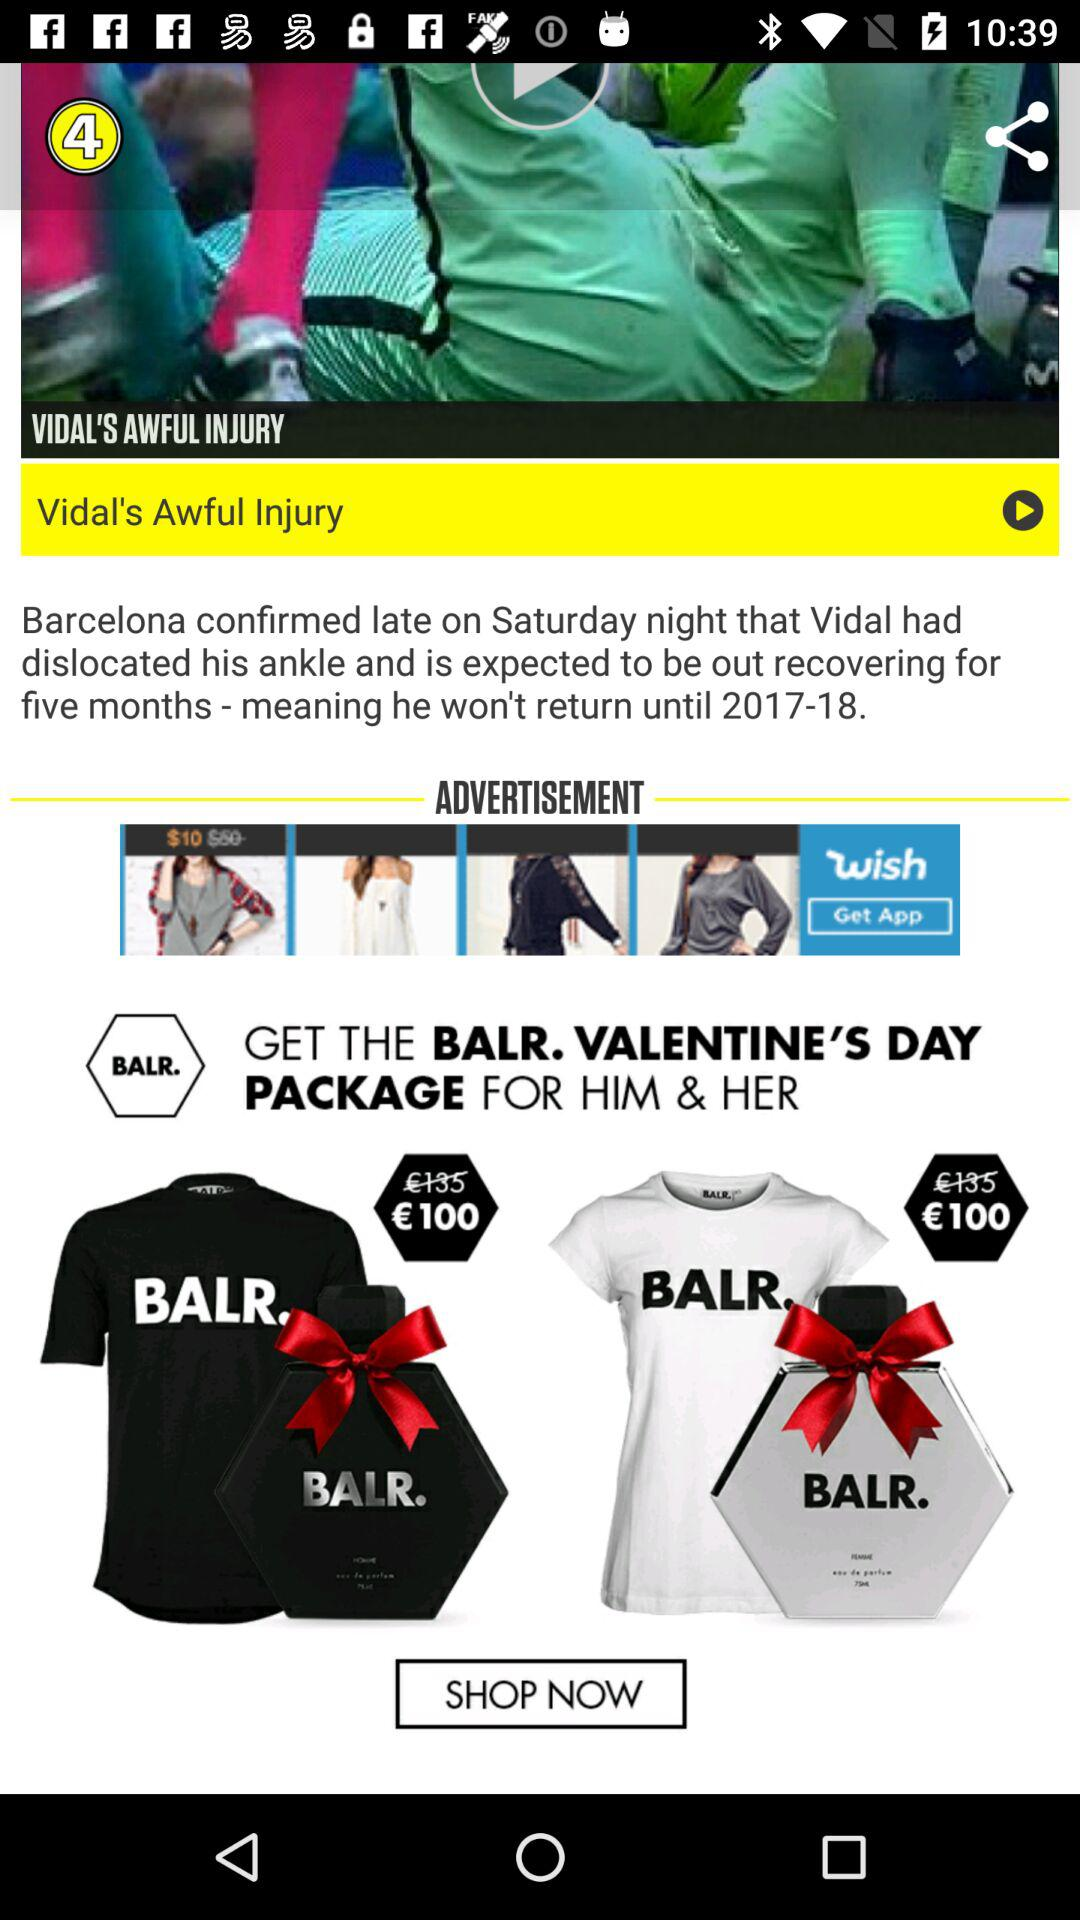How much more is the price of the top T-shirt than the bottom T-shirt?
Answer the question using a single word or phrase. €35 